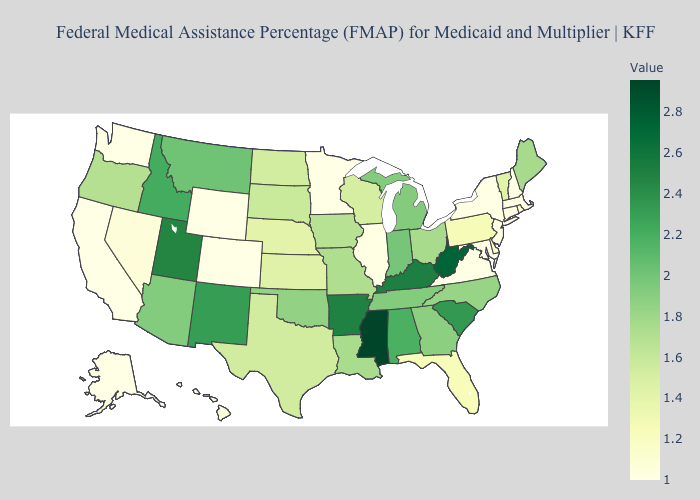Among the states that border Idaho , which have the lowest value?
Short answer required. Washington, Wyoming. Does Nevada have the lowest value in the USA?
Concise answer only. No. Does the map have missing data?
Answer briefly. No. Among the states that border North Carolina , does Virginia have the lowest value?
Quick response, please. Yes. Which states have the lowest value in the MidWest?
Quick response, please. Minnesota. Which states hav the highest value in the South?
Write a very short answer. Mississippi. 